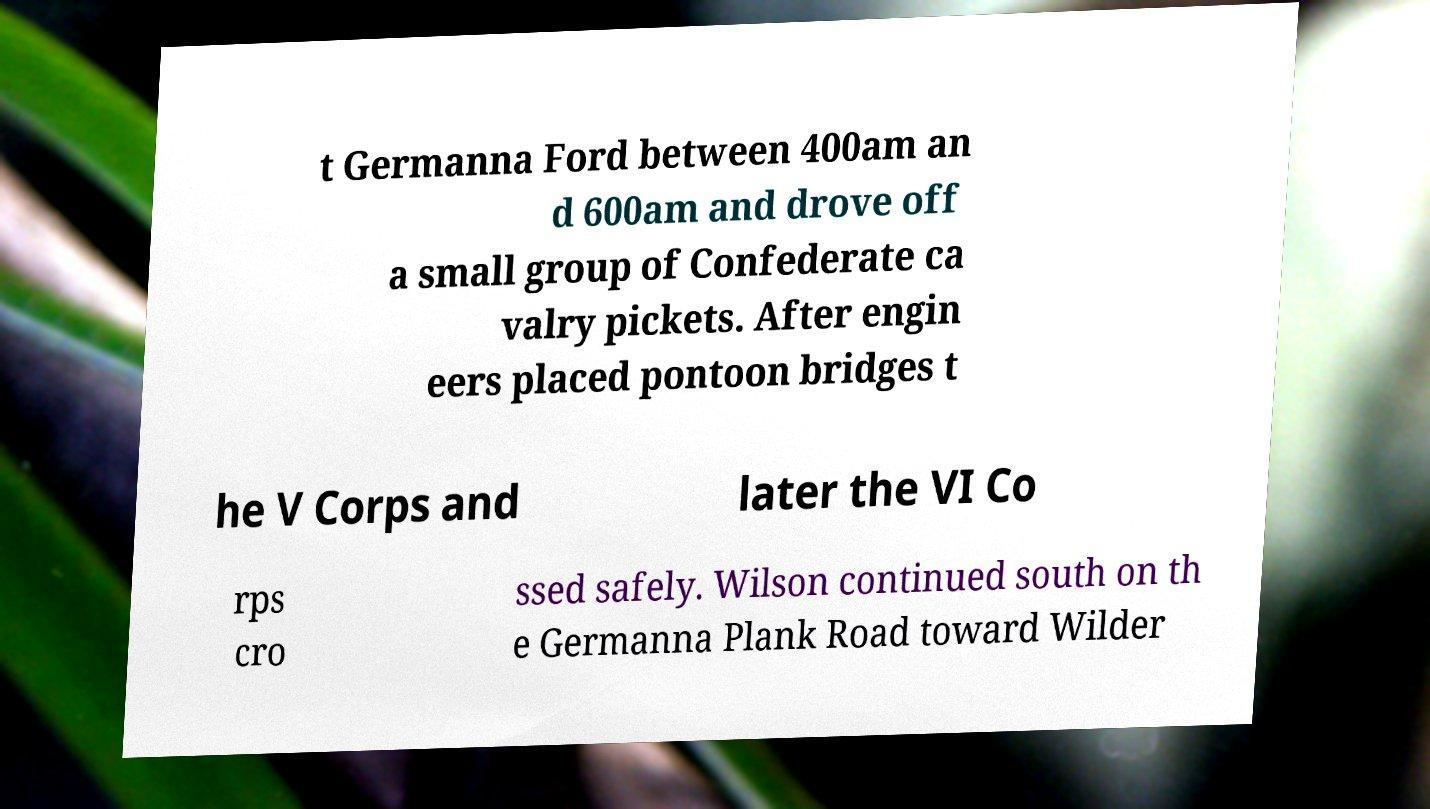Can you read and provide the text displayed in the image?This photo seems to have some interesting text. Can you extract and type it out for me? t Germanna Ford between 400am an d 600am and drove off a small group of Confederate ca valry pickets. After engin eers placed pontoon bridges t he V Corps and later the VI Co rps cro ssed safely. Wilson continued south on th e Germanna Plank Road toward Wilder 